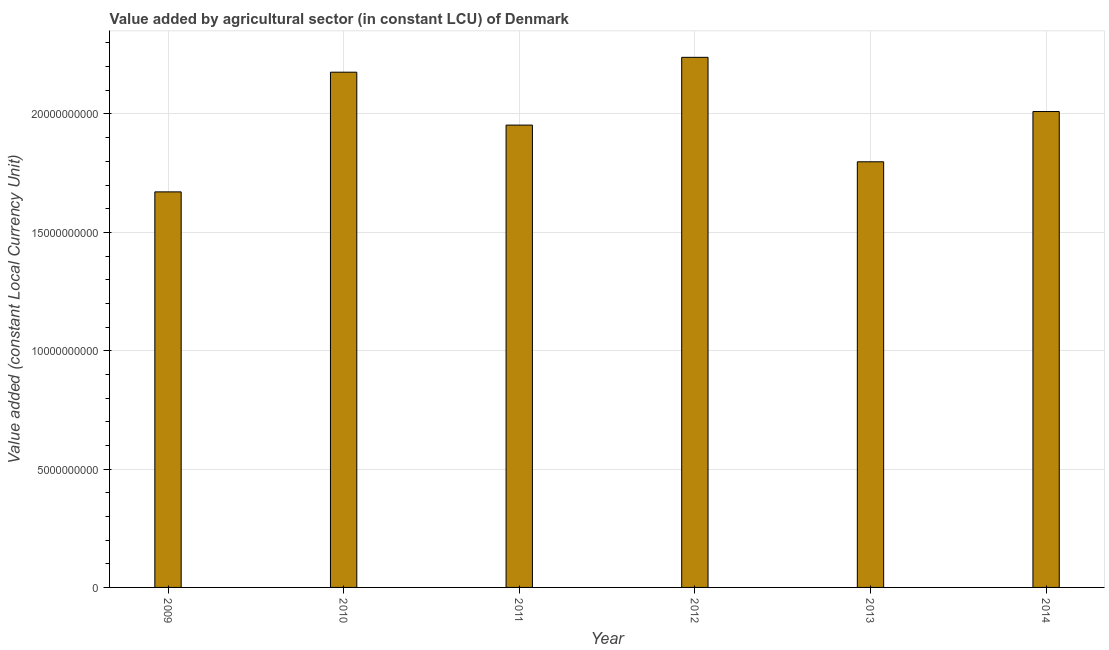Does the graph contain any zero values?
Your answer should be very brief. No. Does the graph contain grids?
Offer a terse response. Yes. What is the title of the graph?
Offer a terse response. Value added by agricultural sector (in constant LCU) of Denmark. What is the label or title of the X-axis?
Keep it short and to the point. Year. What is the label or title of the Y-axis?
Your response must be concise. Value added (constant Local Currency Unit). What is the value added by agriculture sector in 2014?
Offer a very short reply. 2.01e+1. Across all years, what is the maximum value added by agriculture sector?
Ensure brevity in your answer.  2.24e+1. Across all years, what is the minimum value added by agriculture sector?
Your answer should be very brief. 1.67e+1. What is the sum of the value added by agriculture sector?
Ensure brevity in your answer.  1.18e+11. What is the difference between the value added by agriculture sector in 2012 and 2014?
Make the answer very short. 2.29e+09. What is the average value added by agriculture sector per year?
Give a very brief answer. 1.97e+1. What is the median value added by agriculture sector?
Keep it short and to the point. 1.98e+1. In how many years, is the value added by agriculture sector greater than 16000000000 LCU?
Provide a short and direct response. 6. Do a majority of the years between 2014 and 2009 (inclusive) have value added by agriculture sector greater than 1000000000 LCU?
Your answer should be compact. Yes. What is the ratio of the value added by agriculture sector in 2010 to that in 2011?
Offer a terse response. 1.11. Is the value added by agriculture sector in 2010 less than that in 2012?
Make the answer very short. Yes. What is the difference between the highest and the second highest value added by agriculture sector?
Give a very brief answer. 6.28e+08. What is the difference between the highest and the lowest value added by agriculture sector?
Ensure brevity in your answer.  5.68e+09. In how many years, is the value added by agriculture sector greater than the average value added by agriculture sector taken over all years?
Offer a terse response. 3. Are the values on the major ticks of Y-axis written in scientific E-notation?
Offer a very short reply. No. What is the Value added (constant Local Currency Unit) in 2009?
Give a very brief answer. 1.67e+1. What is the Value added (constant Local Currency Unit) in 2010?
Offer a terse response. 2.18e+1. What is the Value added (constant Local Currency Unit) in 2011?
Give a very brief answer. 1.95e+1. What is the Value added (constant Local Currency Unit) in 2012?
Give a very brief answer. 2.24e+1. What is the Value added (constant Local Currency Unit) of 2013?
Your response must be concise. 1.80e+1. What is the Value added (constant Local Currency Unit) of 2014?
Ensure brevity in your answer.  2.01e+1. What is the difference between the Value added (constant Local Currency Unit) in 2009 and 2010?
Your answer should be very brief. -5.06e+09. What is the difference between the Value added (constant Local Currency Unit) in 2009 and 2011?
Offer a terse response. -2.82e+09. What is the difference between the Value added (constant Local Currency Unit) in 2009 and 2012?
Your answer should be very brief. -5.68e+09. What is the difference between the Value added (constant Local Currency Unit) in 2009 and 2013?
Your answer should be very brief. -1.27e+09. What is the difference between the Value added (constant Local Currency Unit) in 2009 and 2014?
Provide a short and direct response. -3.39e+09. What is the difference between the Value added (constant Local Currency Unit) in 2010 and 2011?
Give a very brief answer. 2.24e+09. What is the difference between the Value added (constant Local Currency Unit) in 2010 and 2012?
Offer a very short reply. -6.28e+08. What is the difference between the Value added (constant Local Currency Unit) in 2010 and 2013?
Provide a succinct answer. 3.78e+09. What is the difference between the Value added (constant Local Currency Unit) in 2010 and 2014?
Your answer should be compact. 1.66e+09. What is the difference between the Value added (constant Local Currency Unit) in 2011 and 2012?
Offer a very short reply. -2.86e+09. What is the difference between the Value added (constant Local Currency Unit) in 2011 and 2013?
Keep it short and to the point. 1.55e+09. What is the difference between the Value added (constant Local Currency Unit) in 2011 and 2014?
Make the answer very short. -5.73e+08. What is the difference between the Value added (constant Local Currency Unit) in 2012 and 2013?
Your answer should be very brief. 4.41e+09. What is the difference between the Value added (constant Local Currency Unit) in 2012 and 2014?
Offer a terse response. 2.29e+09. What is the difference between the Value added (constant Local Currency Unit) in 2013 and 2014?
Keep it short and to the point. -2.12e+09. What is the ratio of the Value added (constant Local Currency Unit) in 2009 to that in 2010?
Ensure brevity in your answer.  0.77. What is the ratio of the Value added (constant Local Currency Unit) in 2009 to that in 2011?
Ensure brevity in your answer.  0.86. What is the ratio of the Value added (constant Local Currency Unit) in 2009 to that in 2012?
Ensure brevity in your answer.  0.75. What is the ratio of the Value added (constant Local Currency Unit) in 2009 to that in 2013?
Your answer should be compact. 0.93. What is the ratio of the Value added (constant Local Currency Unit) in 2009 to that in 2014?
Ensure brevity in your answer.  0.83. What is the ratio of the Value added (constant Local Currency Unit) in 2010 to that in 2011?
Provide a short and direct response. 1.11. What is the ratio of the Value added (constant Local Currency Unit) in 2010 to that in 2012?
Keep it short and to the point. 0.97. What is the ratio of the Value added (constant Local Currency Unit) in 2010 to that in 2013?
Make the answer very short. 1.21. What is the ratio of the Value added (constant Local Currency Unit) in 2010 to that in 2014?
Ensure brevity in your answer.  1.08. What is the ratio of the Value added (constant Local Currency Unit) in 2011 to that in 2012?
Keep it short and to the point. 0.87. What is the ratio of the Value added (constant Local Currency Unit) in 2011 to that in 2013?
Keep it short and to the point. 1.09. What is the ratio of the Value added (constant Local Currency Unit) in 2012 to that in 2013?
Offer a terse response. 1.25. What is the ratio of the Value added (constant Local Currency Unit) in 2012 to that in 2014?
Provide a succinct answer. 1.11. What is the ratio of the Value added (constant Local Currency Unit) in 2013 to that in 2014?
Ensure brevity in your answer.  0.89. 